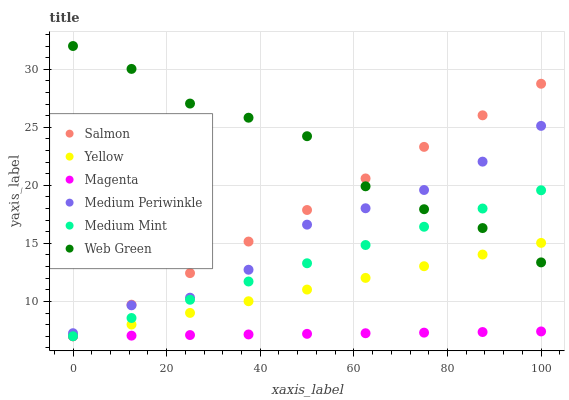Does Magenta have the minimum area under the curve?
Answer yes or no. Yes. Does Web Green have the maximum area under the curve?
Answer yes or no. Yes. Does Salmon have the minimum area under the curve?
Answer yes or no. No. Does Salmon have the maximum area under the curve?
Answer yes or no. No. Is Magenta the smoothest?
Answer yes or no. Yes. Is Web Green the roughest?
Answer yes or no. Yes. Is Salmon the smoothest?
Answer yes or no. No. Is Salmon the roughest?
Answer yes or no. No. Does Medium Mint have the lowest value?
Answer yes or no. Yes. Does Medium Periwinkle have the lowest value?
Answer yes or no. No. Does Web Green have the highest value?
Answer yes or no. Yes. Does Salmon have the highest value?
Answer yes or no. No. Is Magenta less than Medium Periwinkle?
Answer yes or no. Yes. Is Medium Periwinkle greater than Magenta?
Answer yes or no. Yes. Does Yellow intersect Medium Mint?
Answer yes or no. Yes. Is Yellow less than Medium Mint?
Answer yes or no. No. Is Yellow greater than Medium Mint?
Answer yes or no. No. Does Magenta intersect Medium Periwinkle?
Answer yes or no. No. 